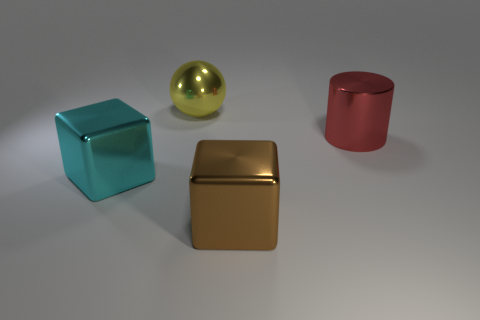Could the placement of these objects have any particular significance? While the placement of objects could be random, it might also be intentional, perhaps to demonstrate contrasts - between geometrical shapes, colors, and textures. For instance, the juxtaposition of the cool turquoise and warm gold hues emphasizes color contrast, and positioning the reflective objects next to the matte red cylinder accentuates textural differences. 